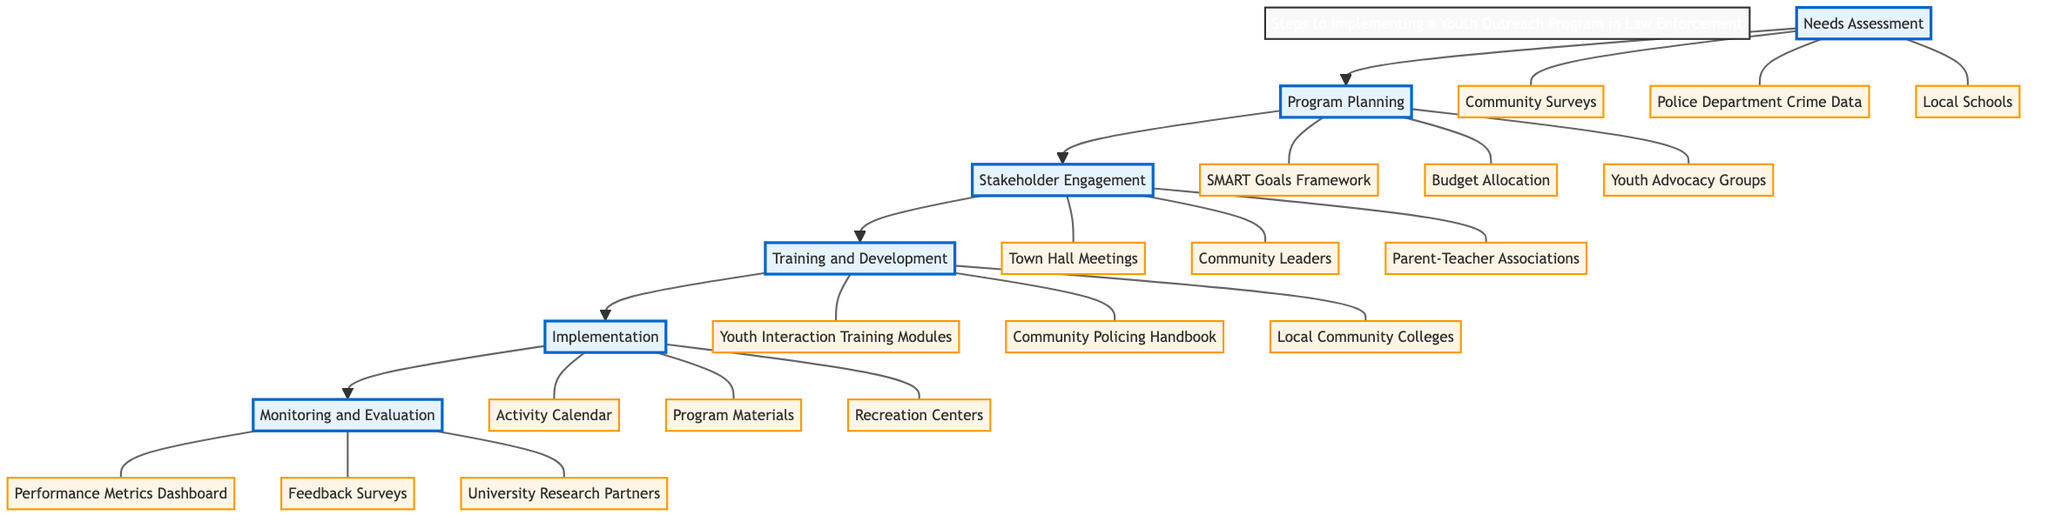What is the first step in the pathway? The first step in the diagram is labeled "Needs Assessment," which is the starting point of the implementation process for the youth outreach program.
Answer: Needs Assessment How many steps are there in the clinical pathway? The diagram shows a total of six steps, which are sequentially arranged.
Answer: 6 What tool is used for Stakeholder Engagement? The tool identified for Stakeholder Engagement is "Town Hall Meetings," which allows for community participation in planning.
Answer: Town Hall Meetings Which step involves the preparation of law enforcement officers? The "Training and Development" step focuses specifically on preparing law enforcement officers with necessary training for youth engagement.
Answer: Training and Development What is the last step of the pathway? The last step in the clinical pathway is "Monitoring and Evaluation," which assesses the program's effectiveness and tracks its progress.
Answer: Monitoring and Evaluation What tool is used in the Needs Assessment step? The tool utilized in the Needs Assessment step is "Community Surveys," which helps gather essential feedback from the community.
Answer: Community Surveys What is the collaborating entity in the Program Planning step? The collaborating entity identified in the Program Planning step is "Youth Advocacy Groups," which helps shape the program structure and goals.
Answer: Youth Advocacy Groups How is program progress tracked in the Monitoring and Evaluation step? Program progress is tracked using a "Performance Metrics Dashboard," which consolidates various metrics to evaluate program effectiveness.
Answer: Performance Metrics Dashboard What are the resources involved in the Implementation step? The resources involved in the Implementation step are "Activity Calendar" and "Program Materials," which are essential for executing the outreach activities.
Answer: Activity Calendar, Program Materials 